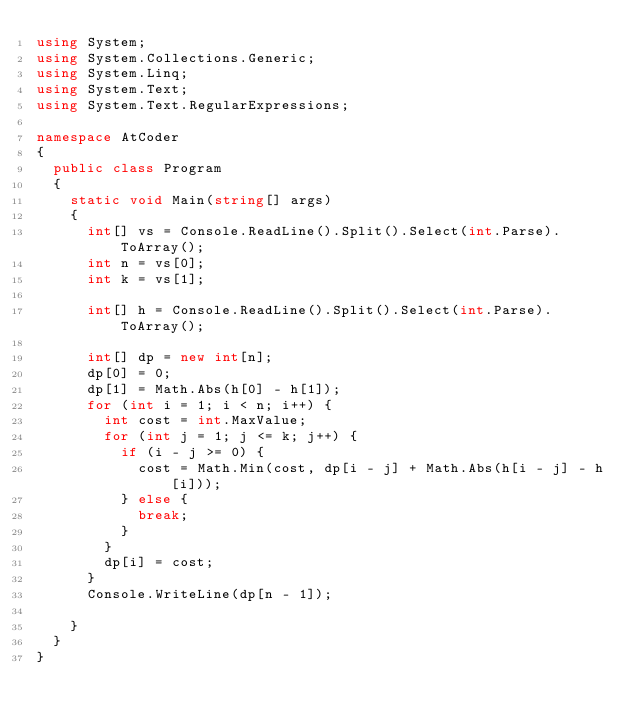<code> <loc_0><loc_0><loc_500><loc_500><_C#_>using System;
using System.Collections.Generic;
using System.Linq;
using System.Text;
using System.Text.RegularExpressions;

namespace AtCoder
{
	public class Program
	{
		static void Main(string[] args)
		{
			int[] vs = Console.ReadLine().Split().Select(int.Parse).ToArray();
			int n = vs[0];
			int k = vs[1];

			int[] h = Console.ReadLine().Split().Select(int.Parse).ToArray();

			int[] dp = new int[n];
			dp[0] = 0;
			dp[1] = Math.Abs(h[0] - h[1]);
			for (int i = 1; i < n; i++) {
				int cost = int.MaxValue;
				for (int j = 1; j <= k; j++) {
					if (i - j >= 0) {
						cost = Math.Min(cost, dp[i - j] + Math.Abs(h[i - j] - h[i]));
					} else {
						break;
					}
				}
				dp[i] = cost;
			}
			Console.WriteLine(dp[n - 1]);

		}
	}
}
</code> 